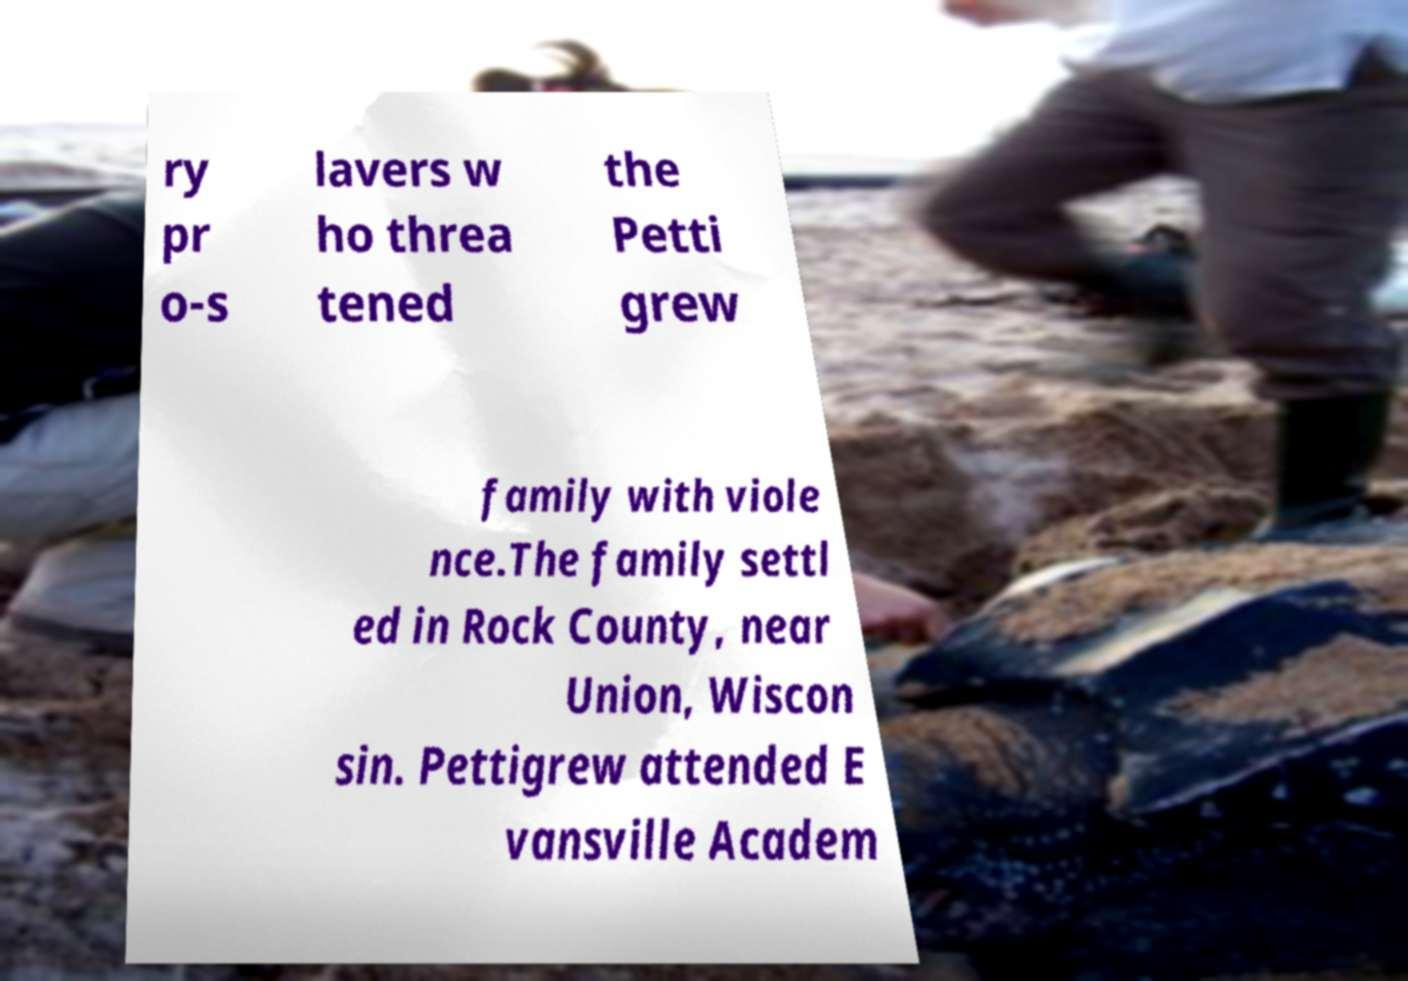I need the written content from this picture converted into text. Can you do that? ry pr o-s lavers w ho threa tened the Petti grew family with viole nce.The family settl ed in Rock County, near Union, Wiscon sin. Pettigrew attended E vansville Academ 